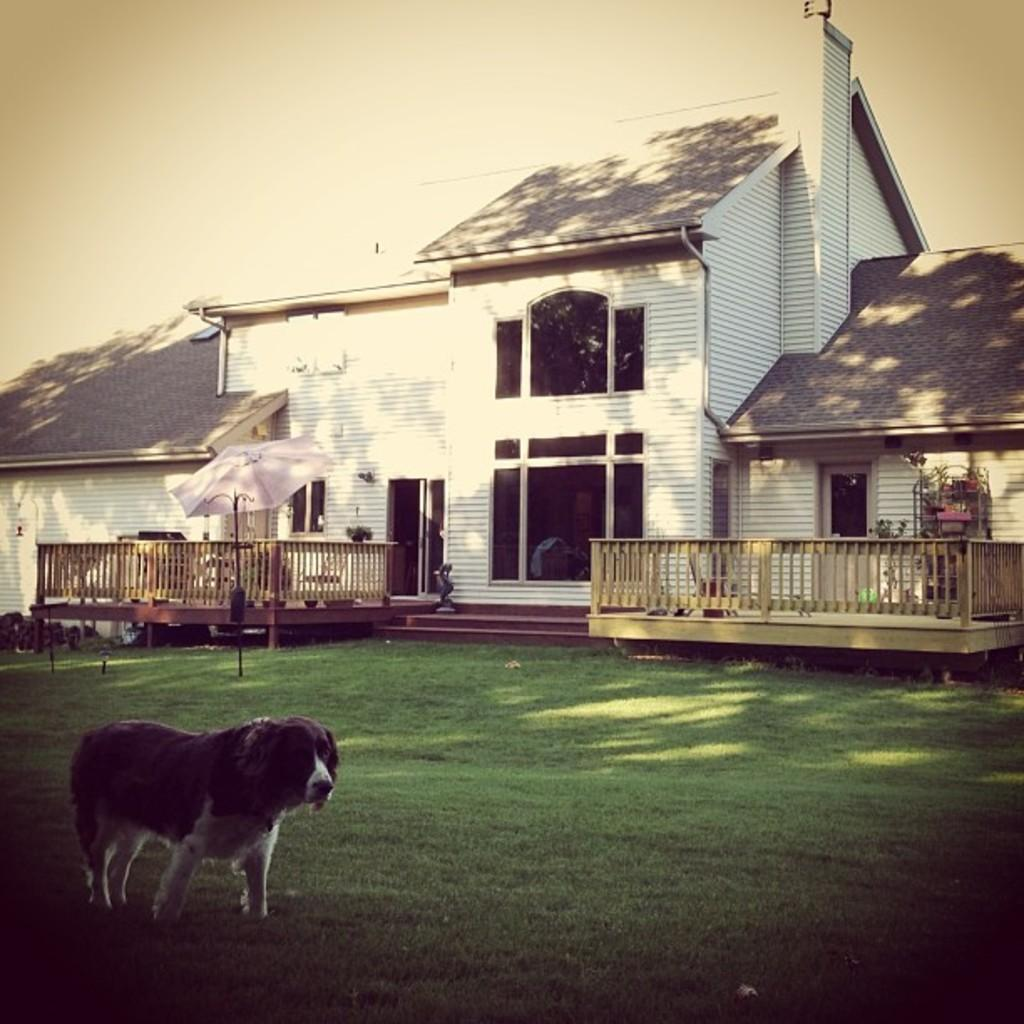What animal can be seen in the image? There is a dog in the image. Where is the dog located? The dog is on grassland. What object is present in the image that provides shade? There is an umbrella in the image. What type of structure can be seen in the image? There are wooden houses in the image. What is visible in the background of the image? The sky is visible in the background of the image. How is the dog connected to the cord in the image? There is no cord present in the image, so the dog is not connected to any cord. 